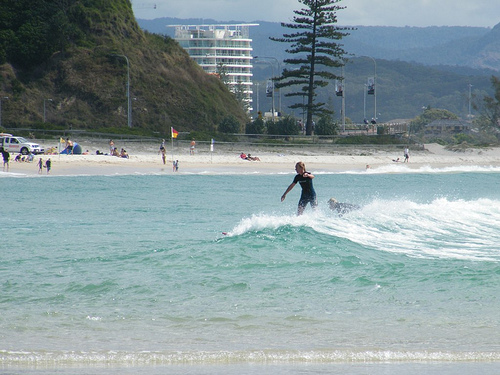Please provide the bounding box coordinate of the region this sentence describes: girl on surfboard. The bounding box coordinates for the girl on the surfboard are [0.56, 0.39, 0.65, 0.58]. These coordinates mark the area where a girl can be seen catching a wave on her surfboard. 